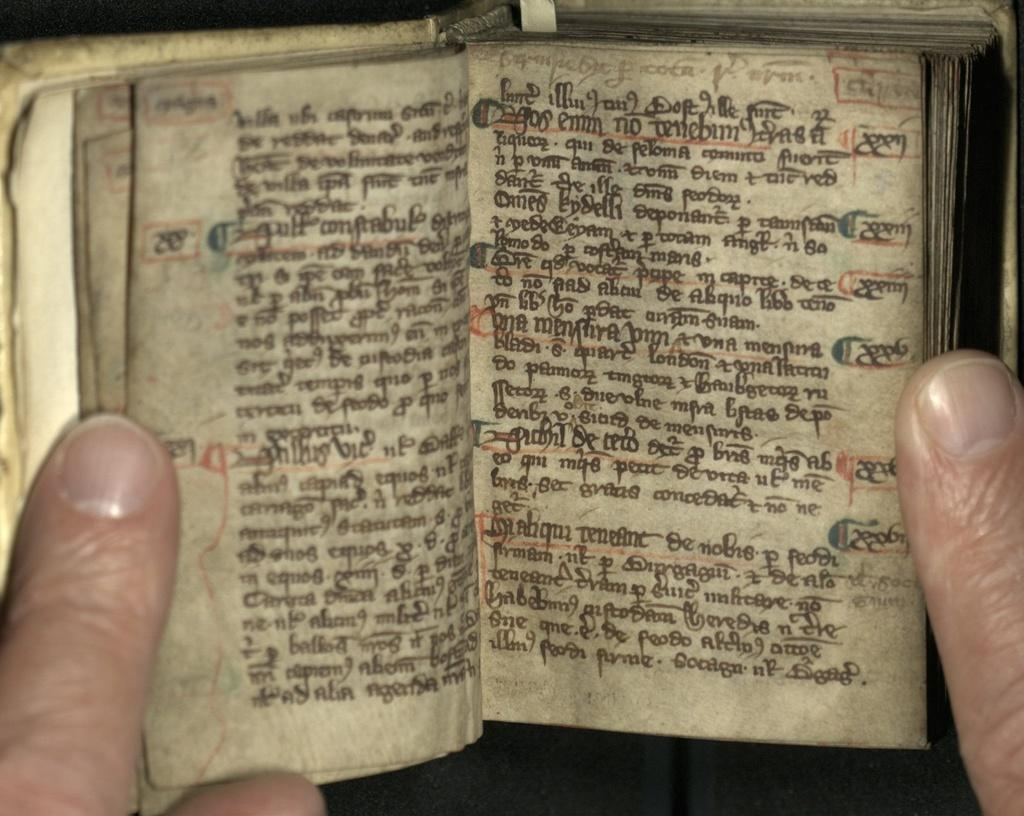What is the main object in the image? There is an opened book with text in the image. What can be inferred about the person in the image? The fingers of a person are visible in the image, suggesting that they might be holding or interacting with the book. What type of nut is being cracked by the person in the image? There is no nut present in the image; it only features an opened book with text and the fingers of a person. 